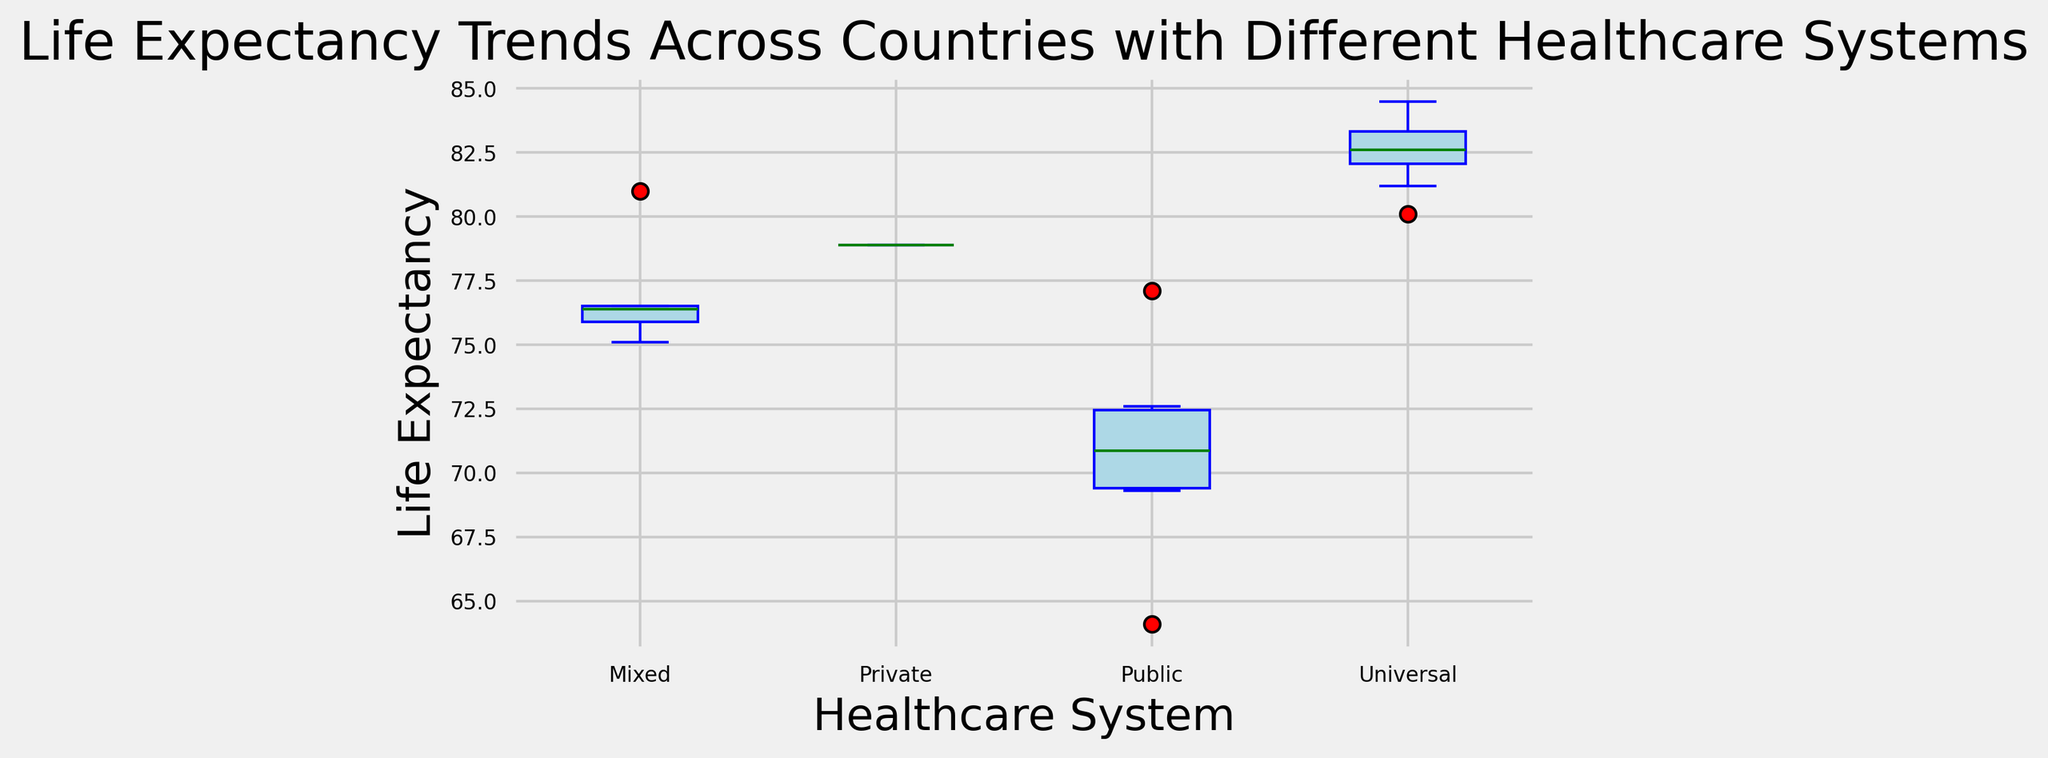What is the median life expectancy for countries with universal healthcare systems? To find the median life expectancy for countries with universal healthcare systems, look for the middle value of the box in the box plot designated for universal healthcare. The median is represented by the green line within the box.
Answer: Approximately 82.6 years Which healthcare system shows the widest range in life expectancy? The range is determined by the distance between the bottom and top whiskers of the box plot. The widest range will be the healthcare system with the longest distance between these whiskers. The box plot for public healthcare has the widest distance between its whiskers.
Answer: Public How does the median life expectancy of countries with private healthcare compare to those with mixed healthcare? First, identify the median values for private and mixed healthcare systems from their respective box plots. The median is the green line inside each box. Then, compare these values.
Answer: Private is lower than Mixed What can you say about the variability in life expectancy for countries with mixed healthcare compared to universal healthcare? Variability is indicated by the interquartile range, which is the height of the box. The higher the box, the more variability there is. Compare the height of the boxes for mixed and universal healthcare systems.
Answer: Mixed has more variability than Universal Which healthcare system has the least variability in life expectancy? Variability is indicated by the interquartile range, the height of the box. The system with the shortest box has the least variability.
Answer: Universal What is the interquartile range (IQR) for countries with public healthcare systems? The interquartile range (IQR) is the difference between the third quartile (top of the box) and the first quartile (bottom of the box). Measure the height of the box for public healthcare systems from the box plot.
Answer: Approximately 6.4 years Are there any outliers in the life expectancy data for any healthcare system? Outliers are indicated by any points outside the whiskers of the box plot. Check each box plot to see if there are dots (outliers) beyond the whiskers.
Answer: No outliers Which healthcare system's median life expectancy is closest to 80 years? Look at the green lines (medians) in each box plot and identify the one closest to the 80-year mark.
Answer: Mixed 